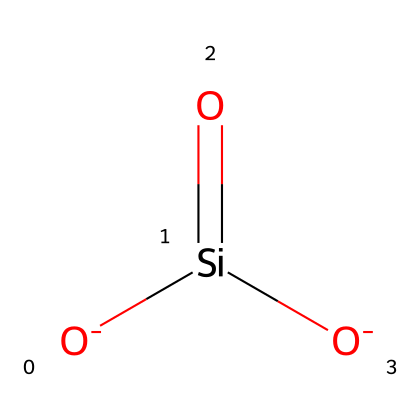What is the primary element in this chemical structure? The SMILES representation shows that silicon (Si) is a key component, indicated by the presence of the silicon atom within the structure.
Answer: silicon How many oxygen atoms are present in this molecule? The chemical structure includes three oxygen atoms: two negatively charged [O-] and one double-bonded [O].
Answer: three What type of bonds are present between silicon and oxygen in this structure? The silicon atom in this molecule forms one double bond with one oxygen atom and two single bonds with the negatively charged oxygen atoms, which suggests covalent bonding.
Answer: covalent What effect do shear-thickening silica nanoparticles have on bulletproof fluids? Shear-thickening silica nanoparticles increase the viscosity of bulletproof fluids under stress, leading to improved impact resistance.
Answer: increased viscosity What does the presence of negatively charged oxygen in this structure imply? The presence of negatively charged oxygen atoms typically indicates that the chemical can participate in ionic interactions, affecting its behavior in non-Newtonian fluids.
Answer: ionic interactions Which characteristic of this chemical contributes to its non-Newtonian behavior? The arrangement of the silica nanoparticles leads to changes in viscosity depending on the applied shear rate, which is a hallmark of non-Newtonian fluids.
Answer: shear rate dependency 